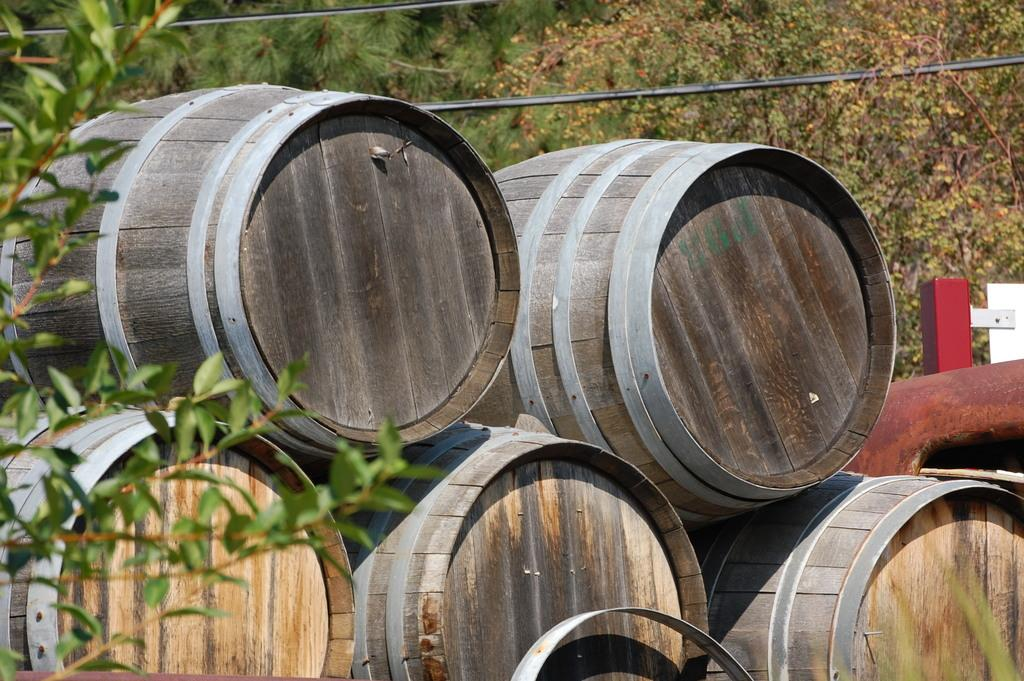What is located on the left side of the image? There is a plant on the left side of the image. What objects can be seen in the image besides the plant? There are barrels and wires visible in the image. What can be seen in the background of the image? There are trees in the background of the image. How many bears are visible in the image? There are no bears present in the image. What type of snakes can be seen slithering through the barrels in the image? There are no snakes present in the image; it features a plant, barrels, and wires. 